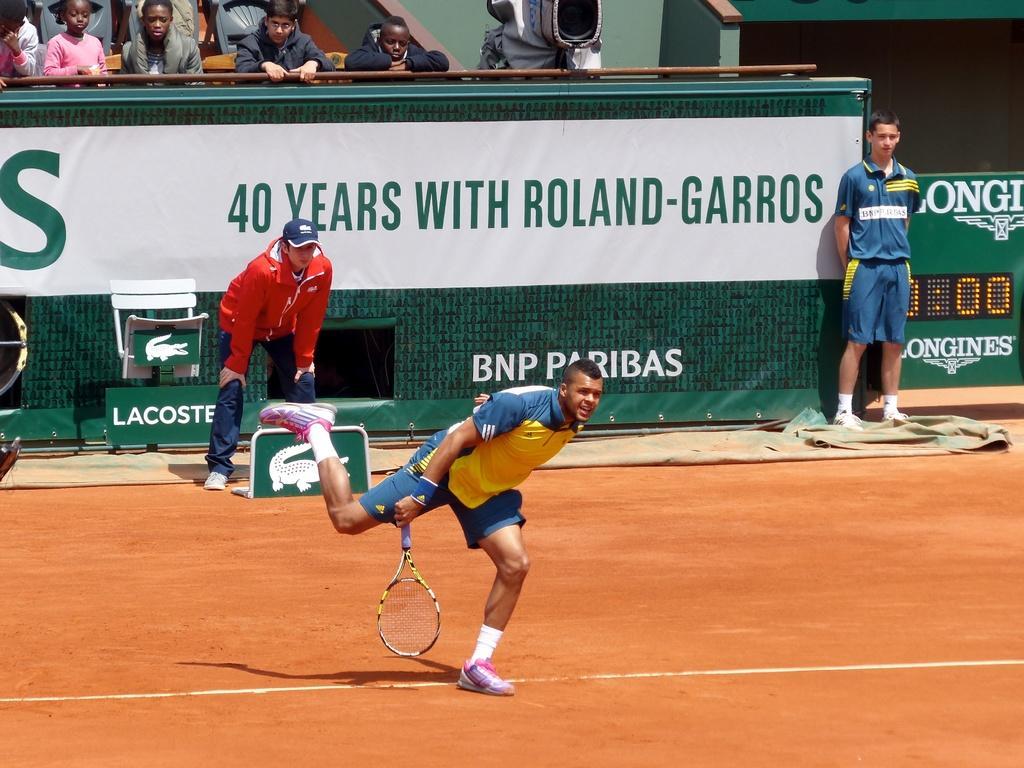How would you summarize this image in a sentence or two? This Image is clicked in ground where in the top there are person sitting and watching the match there is a person on the right side and there is a person in the middle, there is a person who is playing badminton. He is holding a racket and there is a board in the middle of the image. 